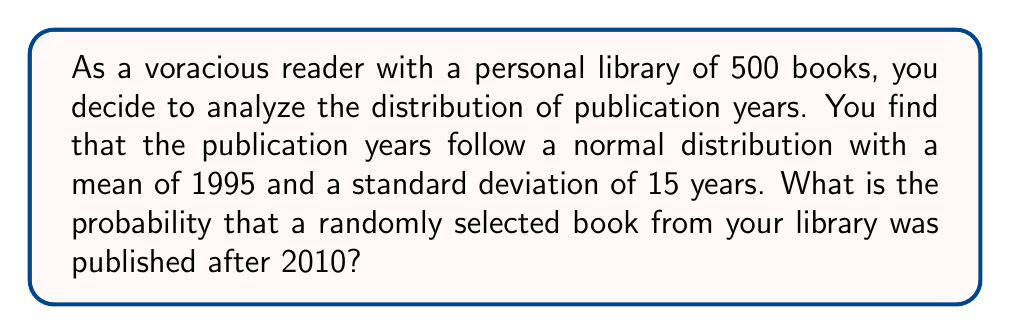Can you solve this math problem? Let's approach this step-by-step:

1) We are given that the publication years follow a normal distribution with:
   $\mu = 1995$ (mean)
   $\sigma = 15$ (standard deviation)

2) We want to find $P(X > 2010)$, where X is the publication year of a randomly selected book.

3) To solve this, we need to standardize the normal distribution. We use the z-score formula:

   $z = \frac{x - \mu}{\sigma}$

   Where x is our cut-off year (2010).

4) Plugging in the values:

   $z = \frac{2010 - 1995}{15} = 1$

5) Now we need to find $P(Z > 1)$ in the standard normal distribution.

6) Using a standard normal table or calculator, we find:

   $P(Z > 1) = 1 - P(Z < 1) = 1 - 0.8413 = 0.1587$

7) Therefore, the probability that a randomly selected book was published after 2010 is approximately 0.1587 or 15.87%.
Answer: 0.1587 